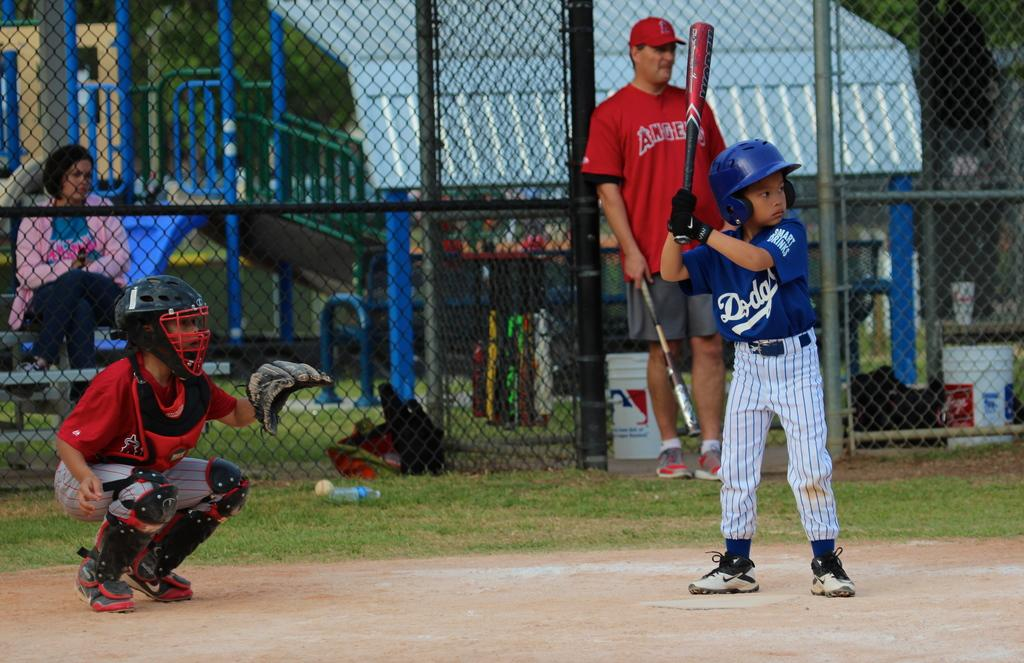Provide a one-sentence caption for the provided image. A coach and catcher for the Angels little league team with a batter from the Dodgers getting ready to swing. 